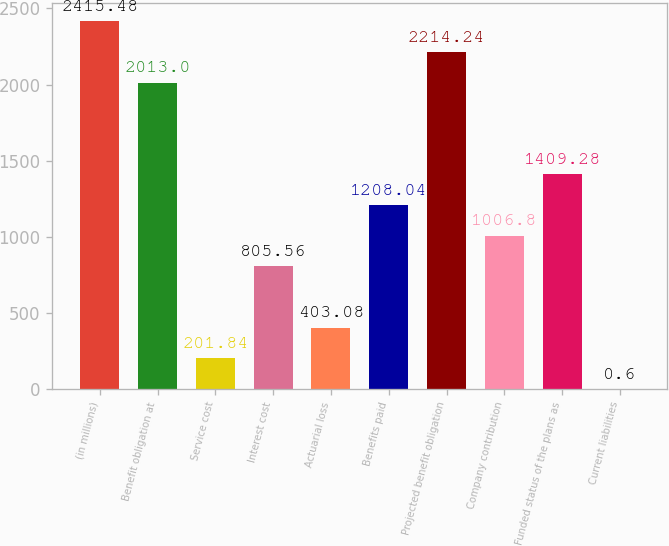Convert chart. <chart><loc_0><loc_0><loc_500><loc_500><bar_chart><fcel>(in millions)<fcel>Benefit obligation at<fcel>Service cost<fcel>Interest cost<fcel>Actuarial loss<fcel>Benefits paid<fcel>Projected benefit obligation<fcel>Company contribution<fcel>Funded status of the plans as<fcel>Current liabilities<nl><fcel>2415.48<fcel>2013<fcel>201.84<fcel>805.56<fcel>403.08<fcel>1208.04<fcel>2214.24<fcel>1006.8<fcel>1409.28<fcel>0.6<nl></chart> 